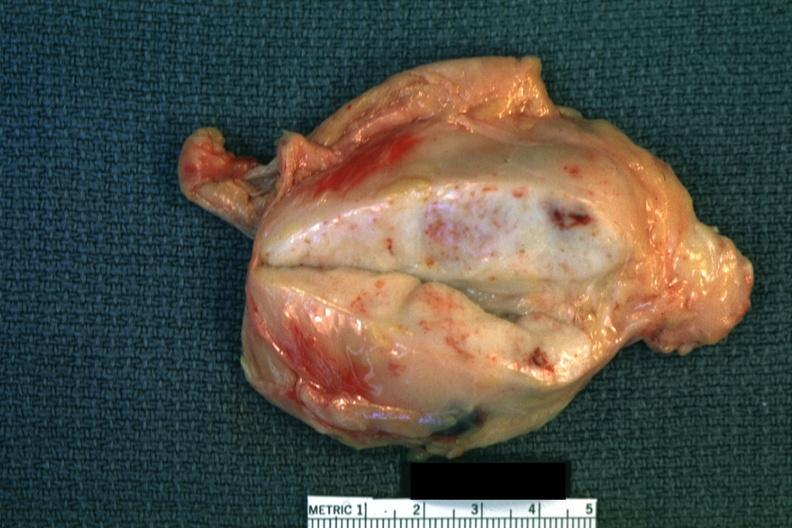what enlarge white node with focal necrosis quite good?
Answer the question using a single word or phrase. Close-up 